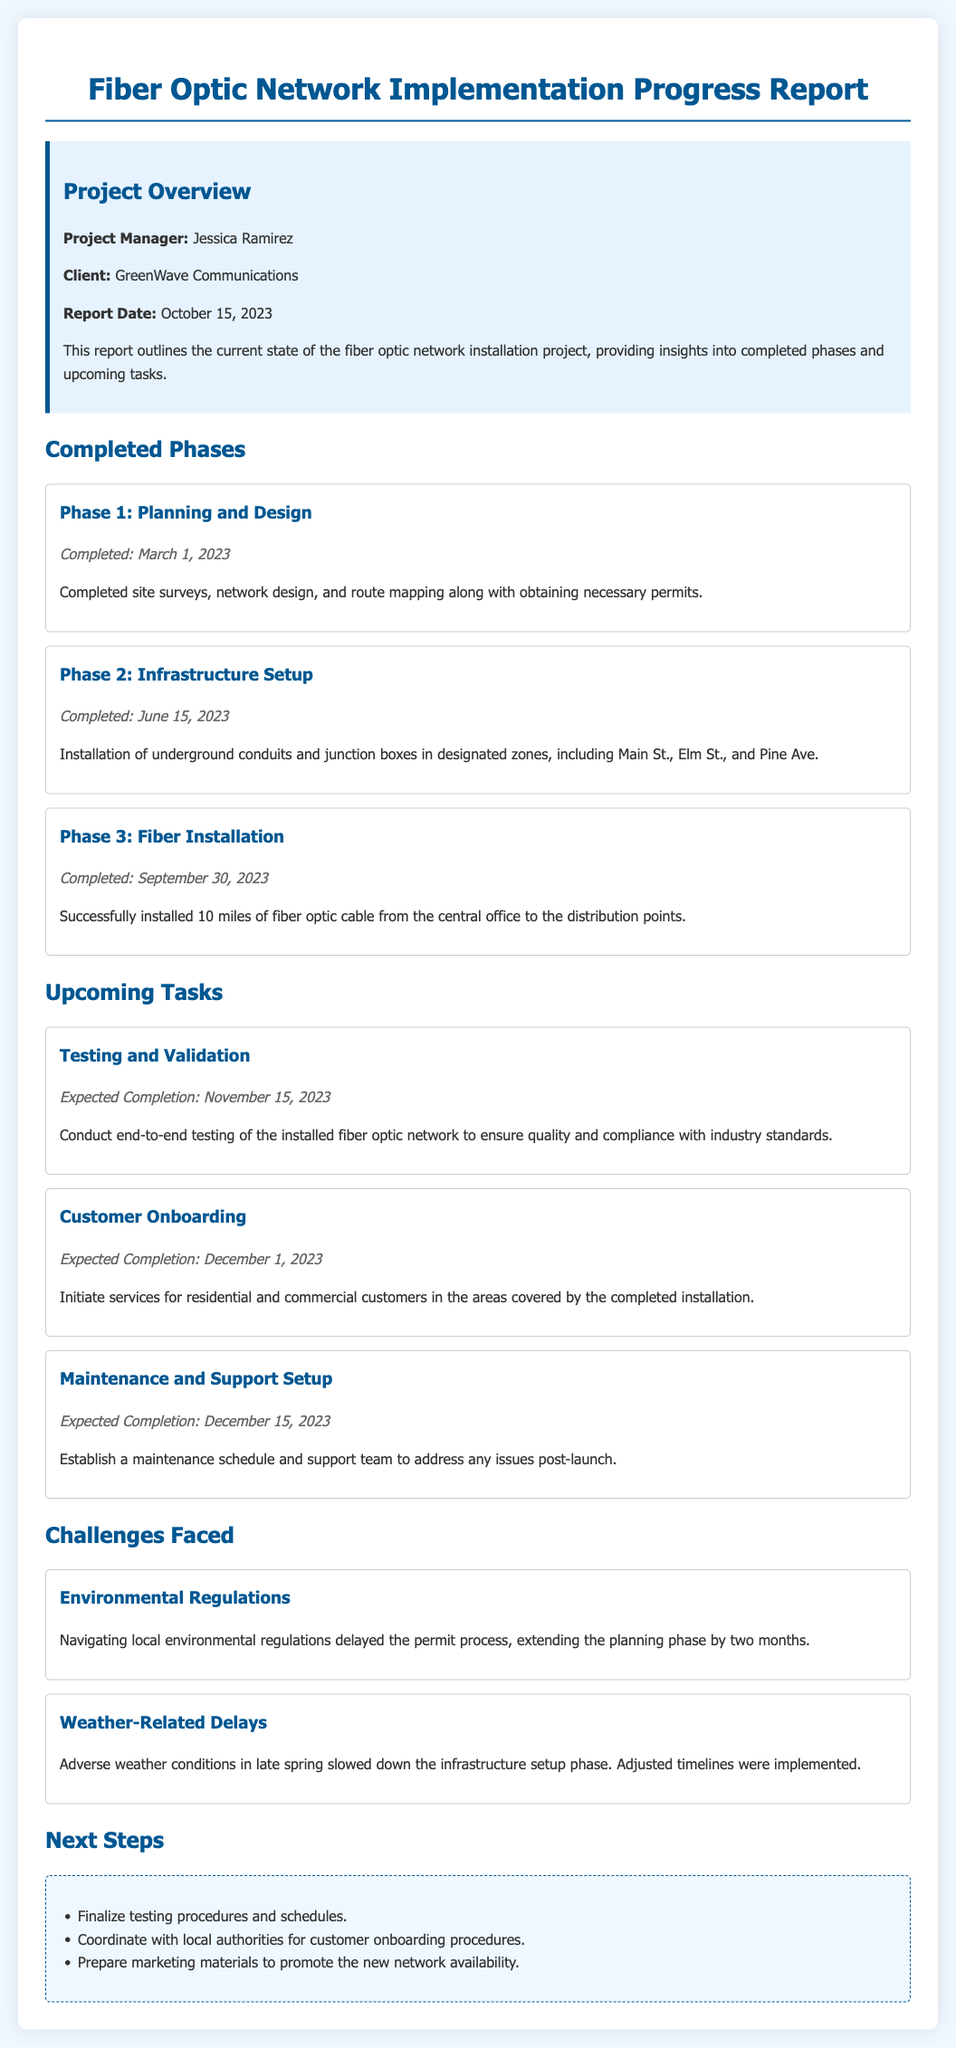What is the project manager's name? The project manager is listed in the overview section of the report as Jessica Ramirez.
Answer: Jessica Ramirez When was Phase 1 completed? Phase 1 is completed on the specific date mentioned in the document under Completed Phases.
Answer: March 1, 2023 What are the upcoming tasks categorized under? There are specific tasks identified under the Upcoming Tasks section in the report.
Answer: Upcoming Tasks How many miles of fiber optic cable were installed? The document states the total miles of fiber optic cable installed in Phase 3 under Completed Phases.
Answer: 10 miles What was the expected completion date for Customer Onboarding? The expected completion date is mentioned clearly in the upcoming tasks section.
Answer: December 1, 2023 What challenge delayed the permit process? The document lists a specific challenge faced, which is related to environmental regulations.
Answer: Environmental Regulations Which phase was completed last? The last completed phase is indicated in the Completed Phases section of the report.
Answer: Phase 3: Fiber Installation What is one of the next steps listed? The document provides a list of next steps in the next steps section, indicating further project actions.
Answer: Finalize testing procedures and schedules 